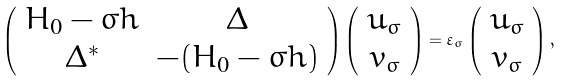<formula> <loc_0><loc_0><loc_500><loc_500>\left ( \begin{array} { c c } H _ { 0 } - \sigma h & \Delta \\ \Delta ^ { \ast } & - ( H _ { 0 } - \bar { \sigma } h ) \\ \end{array} \right ) \left ( \begin{array} { c } u _ { \sigma } \\ v _ { \bar { \sigma } } \end{array} \right ) = \varepsilon _ { \sigma } \left ( \begin{array} { c } u _ { \sigma } \\ v _ { \bar { \sigma } } \end{array} \right ) ,</formula> 